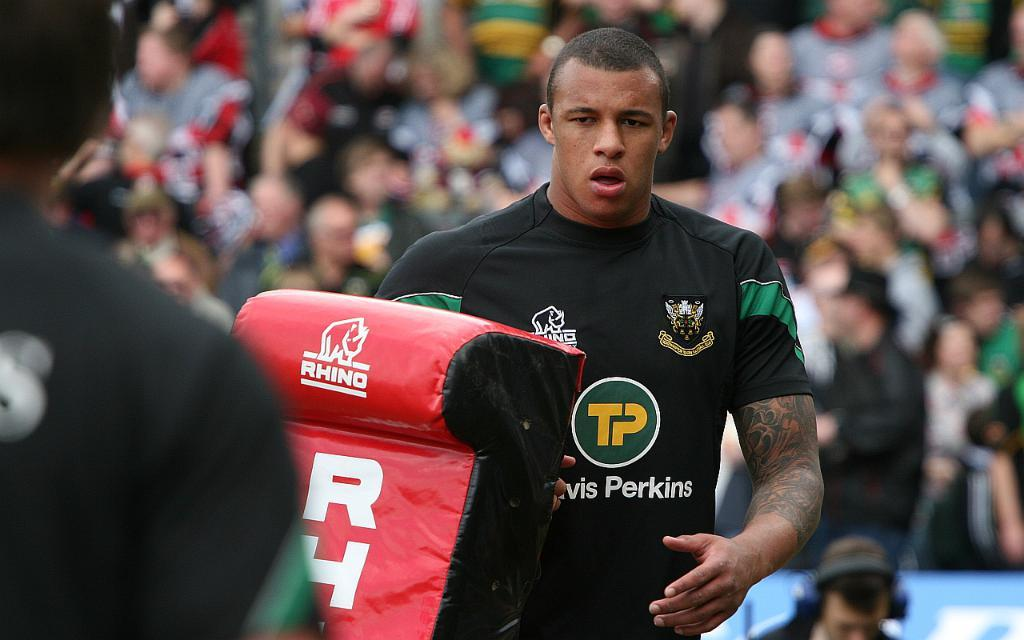How many people are in the image? There are many people in the image. Where are the people located? The people are in a stadium. Can you identify any specific individuals in the image? Yes, there are two players in the image. Is there anyone holding an object in the image? Yes, there is a person holding a red object. What type of design can be seen on the mother's dress in the image? There is no mother or dress present in the image. Can you describe the bee's behavior in the image? There are no bees present in the image. 